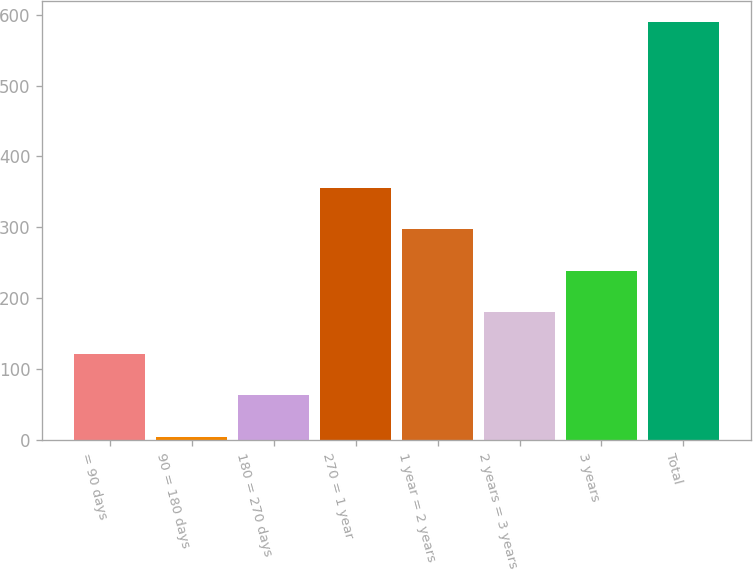Convert chart. <chart><loc_0><loc_0><loc_500><loc_500><bar_chart><fcel>= 90 days<fcel>90 = 180 days<fcel>180 = 270 days<fcel>270 = 1 year<fcel>1 year = 2 years<fcel>2 years = 3 years<fcel>3 years<fcel>Total<nl><fcel>121.4<fcel>4.2<fcel>62.8<fcel>355.8<fcel>297.2<fcel>180<fcel>238.6<fcel>590.2<nl></chart> 